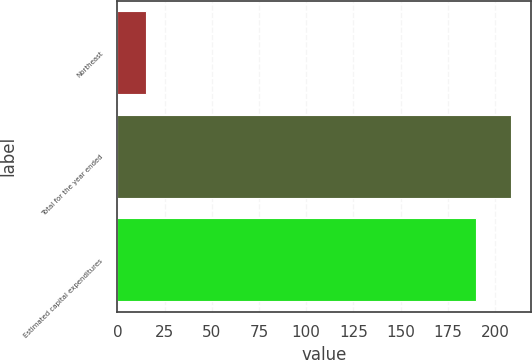<chart> <loc_0><loc_0><loc_500><loc_500><bar_chart><fcel>Northeast<fcel>Total for the year ended<fcel>Estimated capital expenditures<nl><fcel>15<fcel>208.4<fcel>190<nl></chart> 